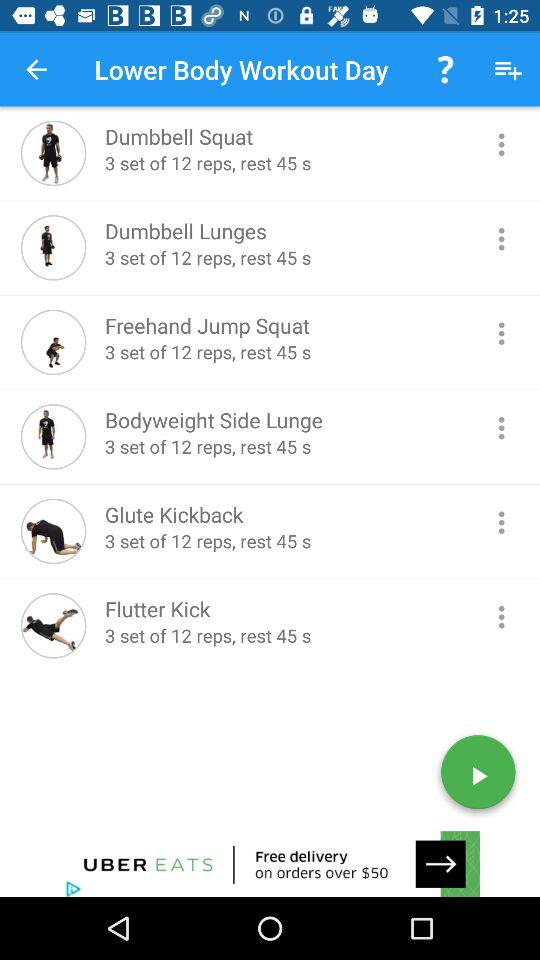How many sets and reps of "Freehand Jump Squat"? There are 3 sets and 12 reps. 